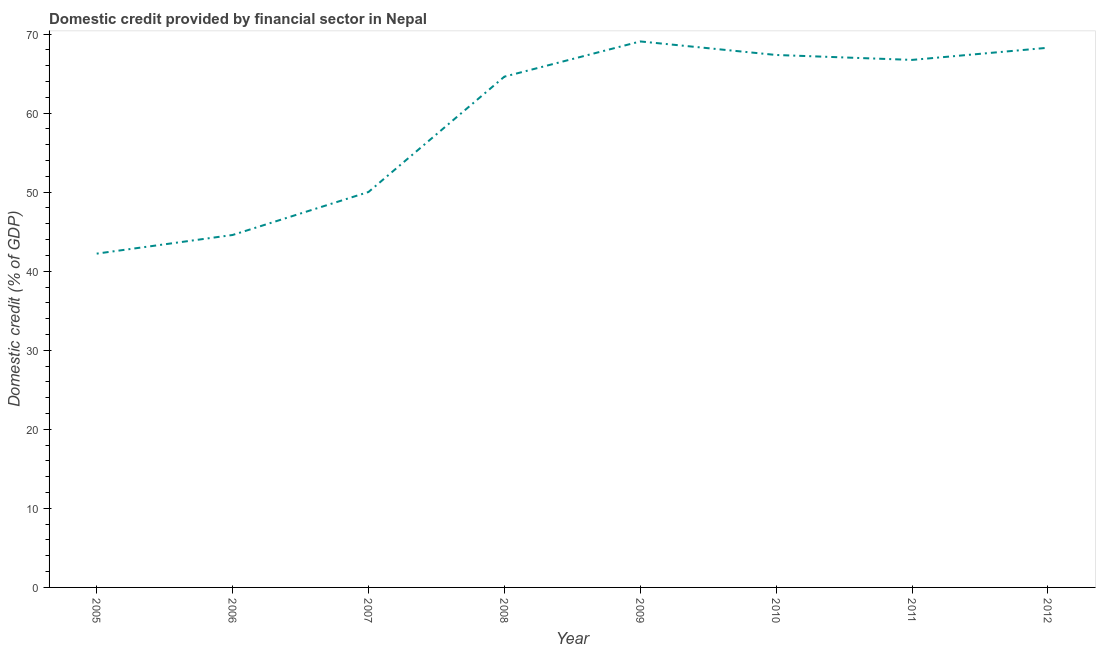What is the domestic credit provided by financial sector in 2009?
Make the answer very short. 69.07. Across all years, what is the maximum domestic credit provided by financial sector?
Make the answer very short. 69.07. Across all years, what is the minimum domestic credit provided by financial sector?
Provide a succinct answer. 42.22. In which year was the domestic credit provided by financial sector minimum?
Offer a terse response. 2005. What is the sum of the domestic credit provided by financial sector?
Ensure brevity in your answer.  472.86. What is the difference between the domestic credit provided by financial sector in 2007 and 2011?
Offer a terse response. -16.71. What is the average domestic credit provided by financial sector per year?
Provide a succinct answer. 59.11. What is the median domestic credit provided by financial sector?
Ensure brevity in your answer.  65.67. In how many years, is the domestic credit provided by financial sector greater than 40 %?
Offer a terse response. 8. Do a majority of the years between 2006 and 2005 (inclusive) have domestic credit provided by financial sector greater than 22 %?
Offer a very short reply. No. What is the ratio of the domestic credit provided by financial sector in 2005 to that in 2012?
Ensure brevity in your answer.  0.62. Is the domestic credit provided by financial sector in 2011 less than that in 2012?
Your response must be concise. Yes. What is the difference between the highest and the second highest domestic credit provided by financial sector?
Give a very brief answer. 0.8. What is the difference between the highest and the lowest domestic credit provided by financial sector?
Give a very brief answer. 26.84. In how many years, is the domestic credit provided by financial sector greater than the average domestic credit provided by financial sector taken over all years?
Give a very brief answer. 5. Does the domestic credit provided by financial sector monotonically increase over the years?
Provide a short and direct response. No. How many lines are there?
Your response must be concise. 1. What is the difference between two consecutive major ticks on the Y-axis?
Provide a succinct answer. 10. Are the values on the major ticks of Y-axis written in scientific E-notation?
Keep it short and to the point. No. Does the graph contain grids?
Give a very brief answer. No. What is the title of the graph?
Offer a very short reply. Domestic credit provided by financial sector in Nepal. What is the label or title of the Y-axis?
Your answer should be very brief. Domestic credit (% of GDP). What is the Domestic credit (% of GDP) in 2005?
Your response must be concise. 42.22. What is the Domestic credit (% of GDP) of 2006?
Provide a succinct answer. 44.58. What is the Domestic credit (% of GDP) in 2007?
Your answer should be very brief. 50.02. What is the Domestic credit (% of GDP) of 2008?
Offer a terse response. 64.61. What is the Domestic credit (% of GDP) in 2009?
Ensure brevity in your answer.  69.07. What is the Domestic credit (% of GDP) of 2010?
Offer a terse response. 67.35. What is the Domestic credit (% of GDP) of 2011?
Provide a short and direct response. 66.73. What is the Domestic credit (% of GDP) in 2012?
Provide a succinct answer. 68.27. What is the difference between the Domestic credit (% of GDP) in 2005 and 2006?
Ensure brevity in your answer.  -2.36. What is the difference between the Domestic credit (% of GDP) in 2005 and 2007?
Provide a short and direct response. -7.8. What is the difference between the Domestic credit (% of GDP) in 2005 and 2008?
Provide a succinct answer. -22.39. What is the difference between the Domestic credit (% of GDP) in 2005 and 2009?
Ensure brevity in your answer.  -26.84. What is the difference between the Domestic credit (% of GDP) in 2005 and 2010?
Keep it short and to the point. -25.13. What is the difference between the Domestic credit (% of GDP) in 2005 and 2011?
Your answer should be very brief. -24.51. What is the difference between the Domestic credit (% of GDP) in 2005 and 2012?
Offer a terse response. -26.04. What is the difference between the Domestic credit (% of GDP) in 2006 and 2007?
Your response must be concise. -5.44. What is the difference between the Domestic credit (% of GDP) in 2006 and 2008?
Provide a short and direct response. -20.03. What is the difference between the Domestic credit (% of GDP) in 2006 and 2009?
Keep it short and to the point. -24.48. What is the difference between the Domestic credit (% of GDP) in 2006 and 2010?
Your answer should be compact. -22.77. What is the difference between the Domestic credit (% of GDP) in 2006 and 2011?
Provide a succinct answer. -22.15. What is the difference between the Domestic credit (% of GDP) in 2006 and 2012?
Give a very brief answer. -23.68. What is the difference between the Domestic credit (% of GDP) in 2007 and 2008?
Make the answer very short. -14.59. What is the difference between the Domestic credit (% of GDP) in 2007 and 2009?
Offer a very short reply. -19.05. What is the difference between the Domestic credit (% of GDP) in 2007 and 2010?
Keep it short and to the point. -17.33. What is the difference between the Domestic credit (% of GDP) in 2007 and 2011?
Ensure brevity in your answer.  -16.71. What is the difference between the Domestic credit (% of GDP) in 2007 and 2012?
Make the answer very short. -18.25. What is the difference between the Domestic credit (% of GDP) in 2008 and 2009?
Your response must be concise. -4.46. What is the difference between the Domestic credit (% of GDP) in 2008 and 2010?
Your answer should be compact. -2.74. What is the difference between the Domestic credit (% of GDP) in 2008 and 2011?
Offer a very short reply. -2.12. What is the difference between the Domestic credit (% of GDP) in 2008 and 2012?
Keep it short and to the point. -3.66. What is the difference between the Domestic credit (% of GDP) in 2009 and 2010?
Your response must be concise. 1.71. What is the difference between the Domestic credit (% of GDP) in 2009 and 2011?
Keep it short and to the point. 2.34. What is the difference between the Domestic credit (% of GDP) in 2009 and 2012?
Provide a short and direct response. 0.8. What is the difference between the Domestic credit (% of GDP) in 2010 and 2011?
Provide a short and direct response. 0.62. What is the difference between the Domestic credit (% of GDP) in 2010 and 2012?
Your answer should be very brief. -0.91. What is the difference between the Domestic credit (% of GDP) in 2011 and 2012?
Give a very brief answer. -1.54. What is the ratio of the Domestic credit (% of GDP) in 2005 to that in 2006?
Offer a terse response. 0.95. What is the ratio of the Domestic credit (% of GDP) in 2005 to that in 2007?
Provide a succinct answer. 0.84. What is the ratio of the Domestic credit (% of GDP) in 2005 to that in 2008?
Offer a terse response. 0.65. What is the ratio of the Domestic credit (% of GDP) in 2005 to that in 2009?
Offer a very short reply. 0.61. What is the ratio of the Domestic credit (% of GDP) in 2005 to that in 2010?
Provide a succinct answer. 0.63. What is the ratio of the Domestic credit (% of GDP) in 2005 to that in 2011?
Provide a short and direct response. 0.63. What is the ratio of the Domestic credit (% of GDP) in 2005 to that in 2012?
Ensure brevity in your answer.  0.62. What is the ratio of the Domestic credit (% of GDP) in 2006 to that in 2007?
Ensure brevity in your answer.  0.89. What is the ratio of the Domestic credit (% of GDP) in 2006 to that in 2008?
Your answer should be compact. 0.69. What is the ratio of the Domestic credit (% of GDP) in 2006 to that in 2009?
Your response must be concise. 0.65. What is the ratio of the Domestic credit (% of GDP) in 2006 to that in 2010?
Your answer should be compact. 0.66. What is the ratio of the Domestic credit (% of GDP) in 2006 to that in 2011?
Your response must be concise. 0.67. What is the ratio of the Domestic credit (% of GDP) in 2006 to that in 2012?
Give a very brief answer. 0.65. What is the ratio of the Domestic credit (% of GDP) in 2007 to that in 2008?
Provide a short and direct response. 0.77. What is the ratio of the Domestic credit (% of GDP) in 2007 to that in 2009?
Offer a terse response. 0.72. What is the ratio of the Domestic credit (% of GDP) in 2007 to that in 2010?
Give a very brief answer. 0.74. What is the ratio of the Domestic credit (% of GDP) in 2007 to that in 2012?
Keep it short and to the point. 0.73. What is the ratio of the Domestic credit (% of GDP) in 2008 to that in 2009?
Give a very brief answer. 0.94. What is the ratio of the Domestic credit (% of GDP) in 2008 to that in 2010?
Make the answer very short. 0.96. What is the ratio of the Domestic credit (% of GDP) in 2008 to that in 2011?
Ensure brevity in your answer.  0.97. What is the ratio of the Domestic credit (% of GDP) in 2008 to that in 2012?
Your response must be concise. 0.95. What is the ratio of the Domestic credit (% of GDP) in 2009 to that in 2010?
Your answer should be very brief. 1.02. What is the ratio of the Domestic credit (% of GDP) in 2009 to that in 2011?
Give a very brief answer. 1.03. What is the ratio of the Domestic credit (% of GDP) in 2009 to that in 2012?
Offer a terse response. 1.01. What is the ratio of the Domestic credit (% of GDP) in 2010 to that in 2012?
Your answer should be compact. 0.99. 